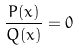<formula> <loc_0><loc_0><loc_500><loc_500>\frac { P ( x ) } { Q ( x ) } = 0</formula> 